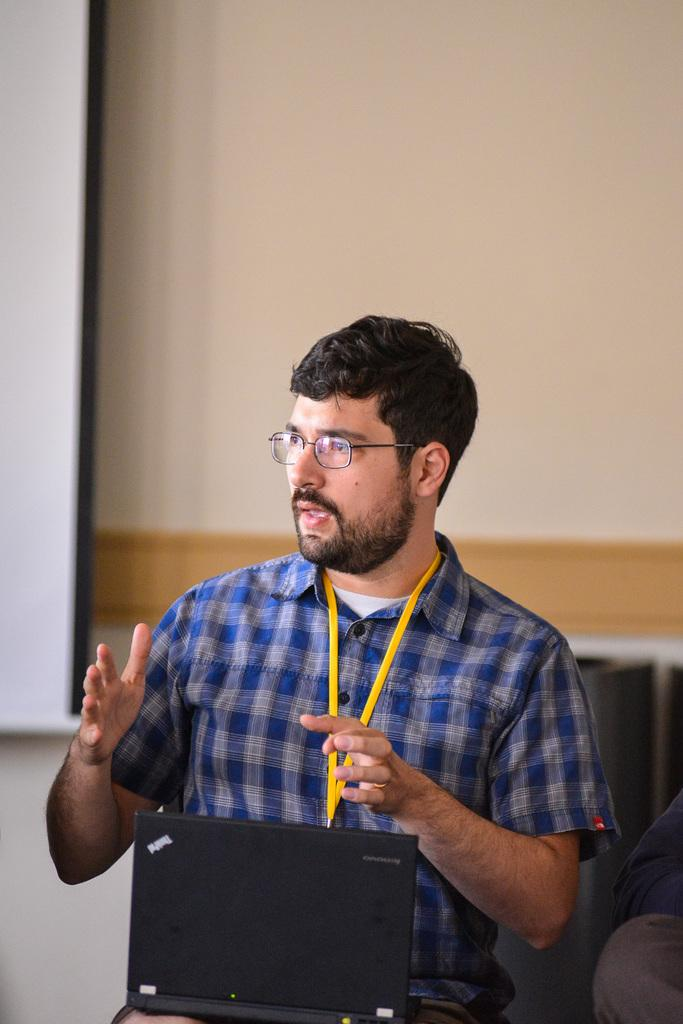What is the man in the image doing? The man is sitting and talking in the image. What object is the man holding? The man is holding a laptop. Can you describe the man's attire? The man is wearing a tag. Who else is present in the image? There is another person beside the man. What can be seen in the background of the image? There is a wall and a banner in the background of the image. What historical event is being discussed by the man in the image? There is no indication of a historical event being discussed in the image. Can you see a horse in the image? No, there is no horse present in the image. 